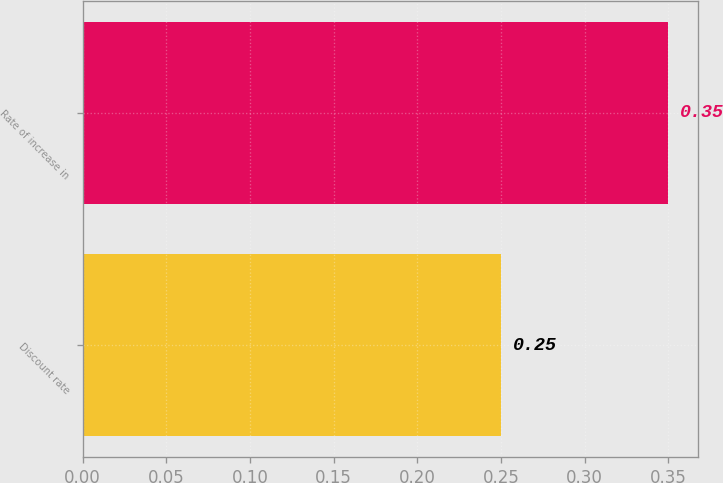Convert chart. <chart><loc_0><loc_0><loc_500><loc_500><bar_chart><fcel>Discount rate<fcel>Rate of increase in<nl><fcel>0.25<fcel>0.35<nl></chart> 